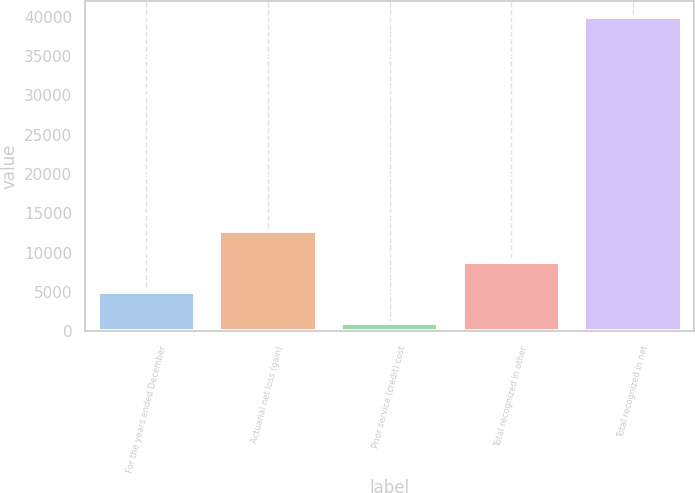Convert chart to OTSL. <chart><loc_0><loc_0><loc_500><loc_500><bar_chart><fcel>For the years ended December<fcel>Actuarial net loss (gain)<fcel>Prior service (credit) cost<fcel>Total recognized in other<fcel>Total recognized in net<nl><fcel>4973.8<fcel>12749.4<fcel>1086<fcel>8861.6<fcel>39964<nl></chart> 